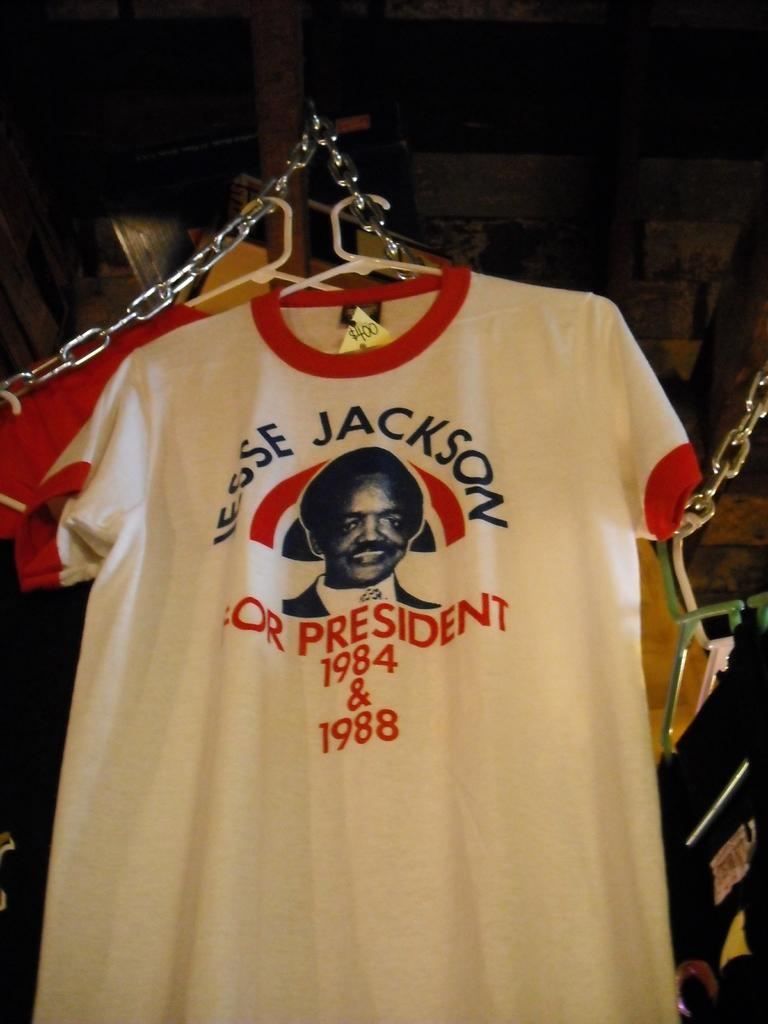Provide a one-sentence caption for the provided image. Tshirts hanging with first tishirt saying "JESSE JACKSON PRESIDENT 1984 & 1988". 